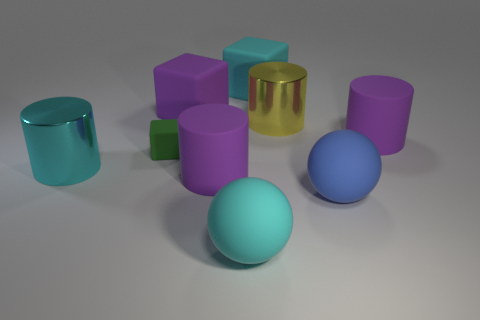Is there a large cyan cylinder that has the same material as the cyan ball?
Give a very brief answer. No. The large blue thing has what shape?
Keep it short and to the point. Sphere. The cyan matte object that is in front of the big block on the left side of the big cyan matte sphere is what shape?
Give a very brief answer. Sphere. What number of other objects are the same shape as the large yellow shiny thing?
Make the answer very short. 3. What is the size of the metallic object left of the big thing that is in front of the large blue rubber object?
Offer a terse response. Large. Is there a large red cylinder?
Your answer should be very brief. No. How many tiny blocks are in front of the big purple cylinder to the left of the cyan block?
Your answer should be very brief. 0. There is a large purple rubber object right of the big blue rubber thing; what shape is it?
Ensure brevity in your answer.  Cylinder. There is a big purple object that is to the right of the big matte block to the right of the large sphere to the left of the blue rubber thing; what is it made of?
Ensure brevity in your answer.  Rubber. What number of other objects are there of the same size as the cyan sphere?
Your answer should be very brief. 7. 